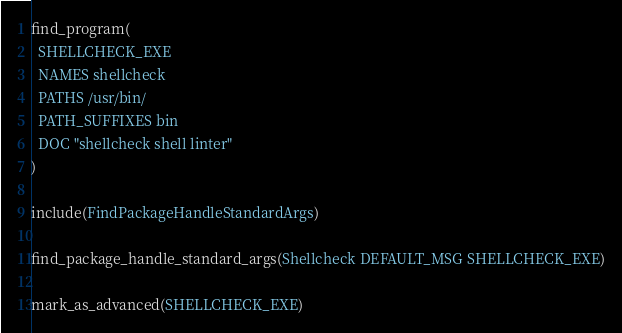Convert code to text. <code><loc_0><loc_0><loc_500><loc_500><_CMake_>find_program(
  SHELLCHECK_EXE
  NAMES shellcheck
  PATHS /usr/bin/
  PATH_SUFFIXES bin
  DOC "shellcheck shell linter"
)

include(FindPackageHandleStandardArgs)

find_package_handle_standard_args(Shellcheck DEFAULT_MSG SHELLCHECK_EXE)

mark_as_advanced(SHELLCHECK_EXE)
</code> 